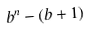<formula> <loc_0><loc_0><loc_500><loc_500>b ^ { n } - ( b + 1 )</formula> 